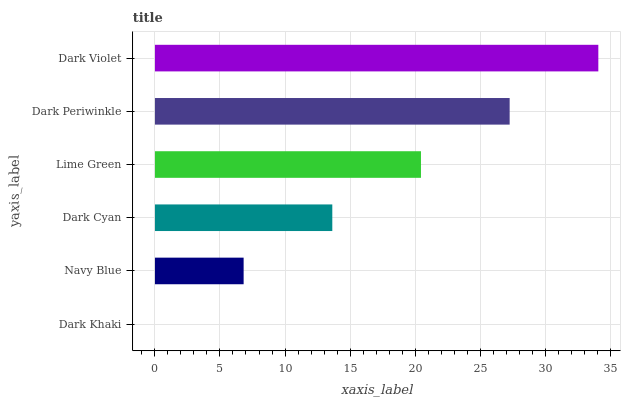Is Dark Khaki the minimum?
Answer yes or no. Yes. Is Dark Violet the maximum?
Answer yes or no. Yes. Is Navy Blue the minimum?
Answer yes or no. No. Is Navy Blue the maximum?
Answer yes or no. No. Is Navy Blue greater than Dark Khaki?
Answer yes or no. Yes. Is Dark Khaki less than Navy Blue?
Answer yes or no. Yes. Is Dark Khaki greater than Navy Blue?
Answer yes or no. No. Is Navy Blue less than Dark Khaki?
Answer yes or no. No. Is Lime Green the high median?
Answer yes or no. Yes. Is Dark Cyan the low median?
Answer yes or no. Yes. Is Dark Violet the high median?
Answer yes or no. No. Is Navy Blue the low median?
Answer yes or no. No. 